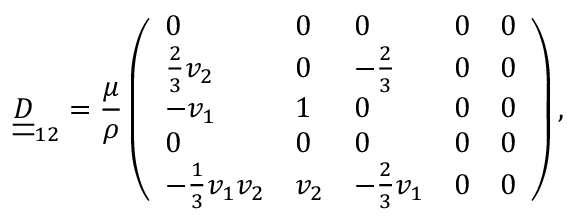<formula> <loc_0><loc_0><loc_500><loc_500>\underline { { \underline { D } } } _ { 1 2 } = \frac { \mu } { \rho } \left ( \begin{array} { l l l l l } { 0 } & { 0 } & { 0 } & { 0 } & { 0 } \\ { \frac { 2 } { 3 } v _ { 2 } } & { 0 } & { - \frac { 2 } { 3 } } & { 0 } & { 0 } \\ { - v _ { 1 } } & { 1 } & { 0 } & { 0 } & { 0 } \\ { 0 } & { 0 } & { 0 } & { 0 } & { 0 } \\ { - \frac { 1 } { 3 } v _ { 1 } v _ { 2 } } & { v _ { 2 } } & { - \frac { 2 } { 3 } v _ { 1 } } & { 0 } & { 0 } \end{array} \right ) ,</formula> 